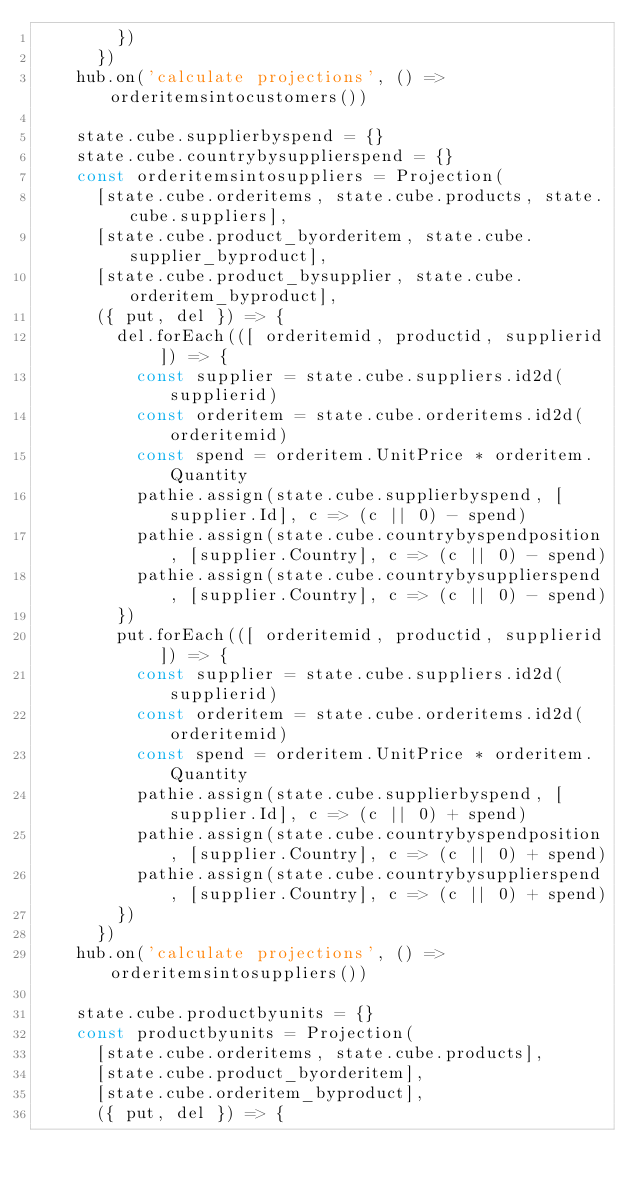<code> <loc_0><loc_0><loc_500><loc_500><_JavaScript_>        })
      })
    hub.on('calculate projections', () => orderitemsintocustomers())

    state.cube.supplierbyspend = {}
    state.cube.countrybysupplierspend = {}
    const orderitemsintosuppliers = Projection(
      [state.cube.orderitems, state.cube.products, state.cube.suppliers],
      [state.cube.product_byorderitem, state.cube.supplier_byproduct],
      [state.cube.product_bysupplier, state.cube.orderitem_byproduct],
      ({ put, del }) => {
        del.forEach(([ orderitemid, productid, supplierid ]) => {
          const supplier = state.cube.suppliers.id2d(supplierid)
          const orderitem = state.cube.orderitems.id2d(orderitemid)
          const spend = orderitem.UnitPrice * orderitem.Quantity
          pathie.assign(state.cube.supplierbyspend, [supplier.Id], c => (c || 0) - spend)
          pathie.assign(state.cube.countrybyspendposition, [supplier.Country], c => (c || 0) - spend)
          pathie.assign(state.cube.countrybysupplierspend, [supplier.Country], c => (c || 0) - spend)
        })
        put.forEach(([ orderitemid, productid, supplierid ]) => {
          const supplier = state.cube.suppliers.id2d(supplierid)
          const orderitem = state.cube.orderitems.id2d(orderitemid)
          const spend = orderitem.UnitPrice * orderitem.Quantity
          pathie.assign(state.cube.supplierbyspend, [supplier.Id], c => (c || 0) + spend)
          pathie.assign(state.cube.countrybyspendposition, [supplier.Country], c => (c || 0) + spend)
          pathie.assign(state.cube.countrybysupplierspend, [supplier.Country], c => (c || 0) + spend)
        })
      })
    hub.on('calculate projections', () => orderitemsintosuppliers())

    state.cube.productbyunits = {}
    const productbyunits = Projection(
      [state.cube.orderitems, state.cube.products],
      [state.cube.product_byorderitem],
      [state.cube.orderitem_byproduct],
      ({ put, del }) => {</code> 